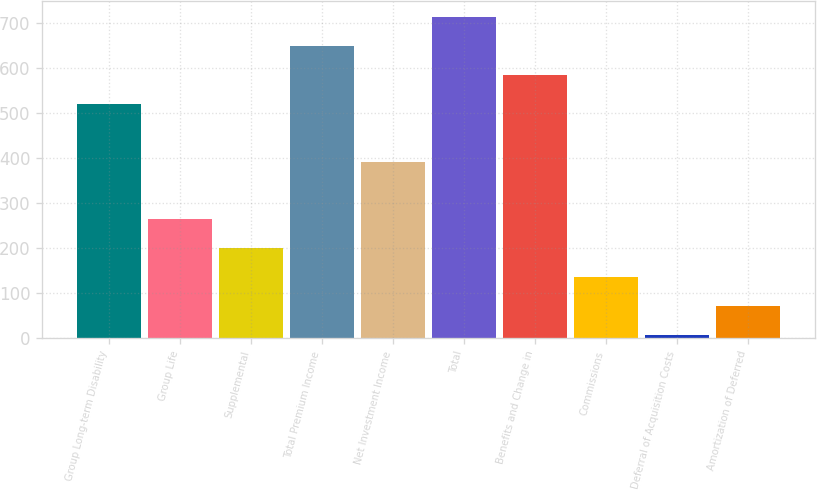Convert chart. <chart><loc_0><loc_0><loc_500><loc_500><bar_chart><fcel>Group Long-term Disability<fcel>Group Life<fcel>Supplemental<fcel>Total Premium Income<fcel>Net Investment Income<fcel>Total<fcel>Benefits and Change in<fcel>Commissions<fcel>Deferral of Acquisition Costs<fcel>Amortization of Deferred<nl><fcel>519.72<fcel>263.96<fcel>200.02<fcel>647.6<fcel>391.84<fcel>711.54<fcel>583.66<fcel>136.08<fcel>8.2<fcel>72.14<nl></chart> 